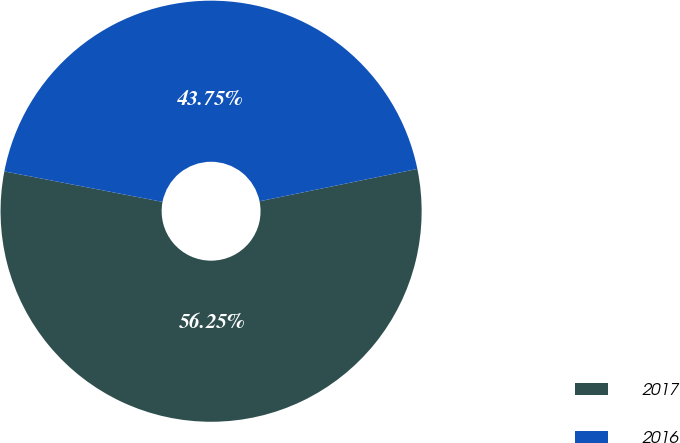Convert chart. <chart><loc_0><loc_0><loc_500><loc_500><pie_chart><fcel>2017<fcel>2016<nl><fcel>56.25%<fcel>43.75%<nl></chart> 